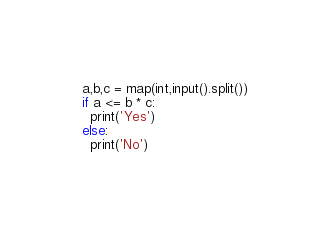Convert code to text. <code><loc_0><loc_0><loc_500><loc_500><_Python_>a,b,c = map(int,input().split())
if a <= b * c:
  print('Yes')
else:
  print('No')</code> 